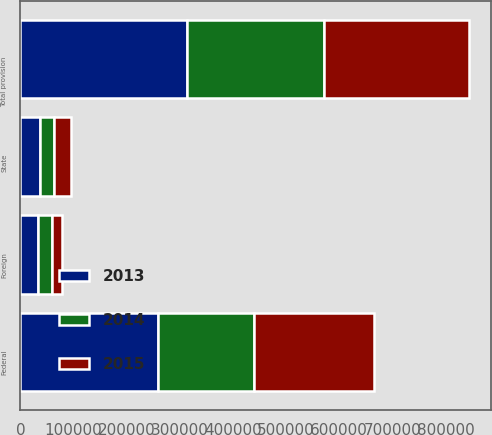<chart> <loc_0><loc_0><loc_500><loc_500><stacked_bar_chart><ecel><fcel>Federal<fcel>State<fcel>Foreign<fcel>Total provision<nl><fcel>2013<fcel>259793<fcel>37129<fcel>33255<fcel>313082<nl><fcel>2015<fcel>224468<fcel>32110<fcel>20259<fcel>273720<nl><fcel>2014<fcel>180351<fcel>26351<fcel>25529<fcel>257457<nl></chart> 